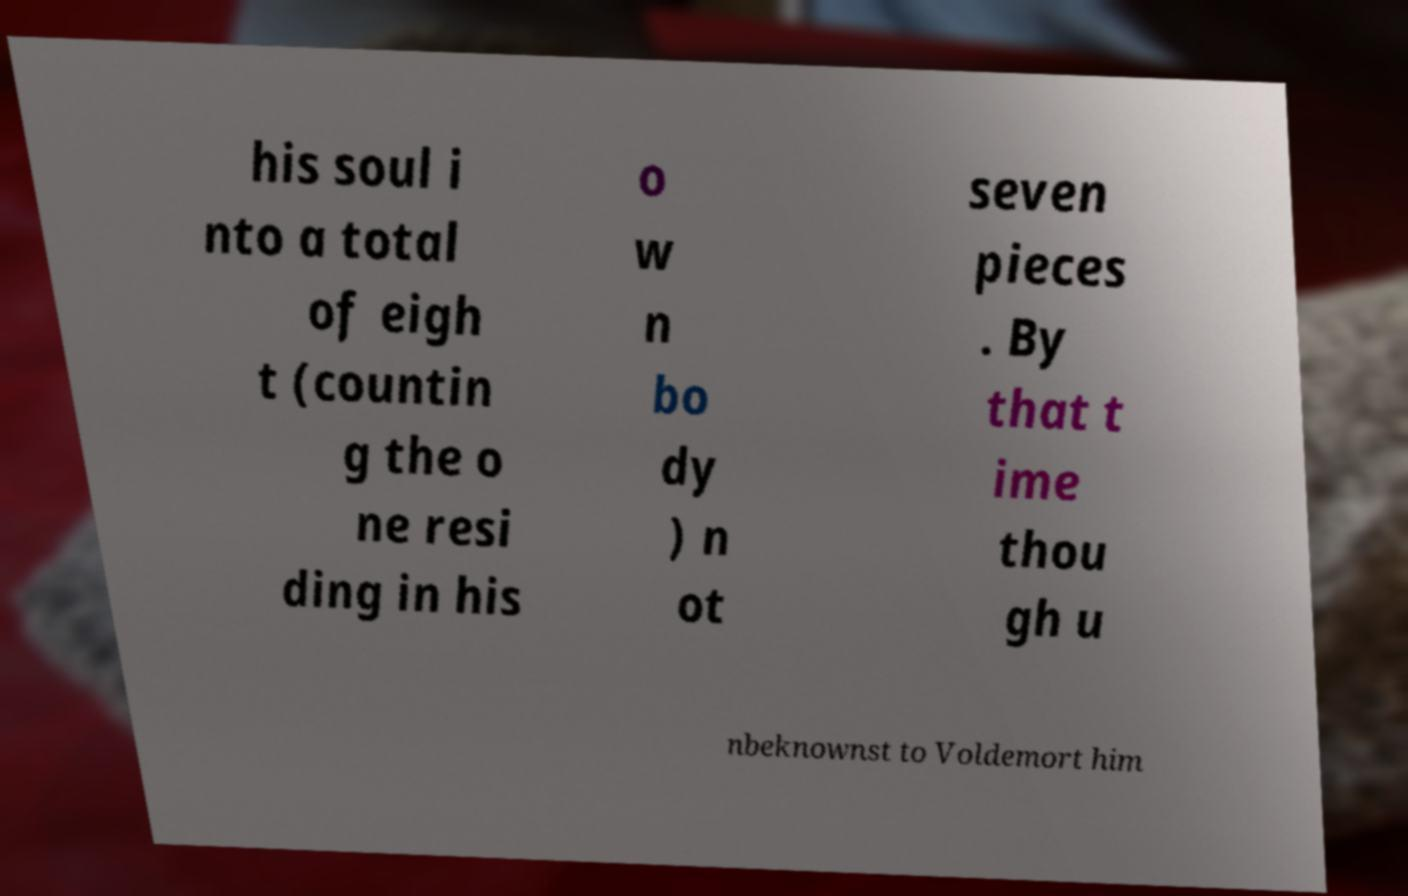Please read and relay the text visible in this image. What does it say? his soul i nto a total of eigh t (countin g the o ne resi ding in his o w n bo dy ) n ot seven pieces . By that t ime thou gh u nbeknownst to Voldemort him 